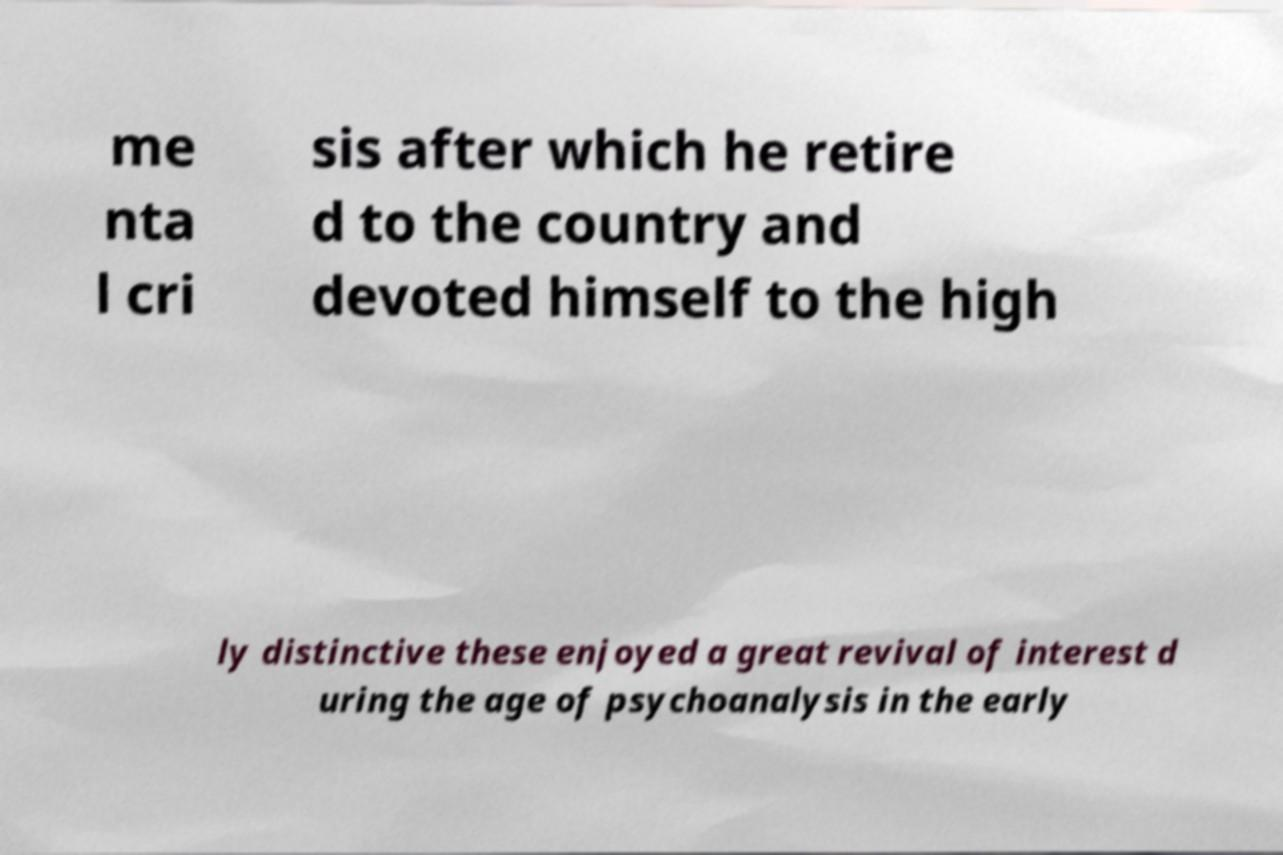I need the written content from this picture converted into text. Can you do that? me nta l cri sis after which he retire d to the country and devoted himself to the high ly distinctive these enjoyed a great revival of interest d uring the age of psychoanalysis in the early 